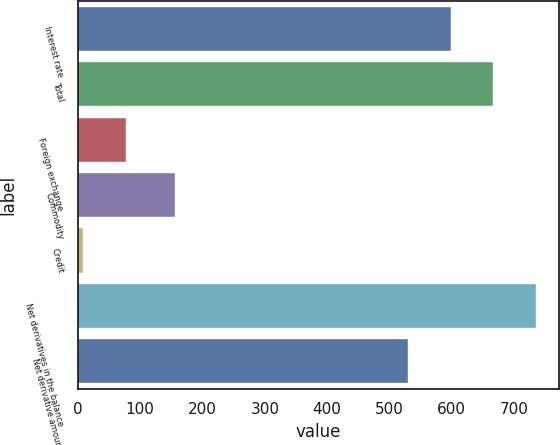Convert chart to OTSL. <chart><loc_0><loc_0><loc_500><loc_500><bar_chart><fcel>Interest rate<fcel>Total<fcel>Foreign exchange<fcel>Commodity<fcel>Credit<fcel>Net derivatives in the balance<fcel>Net derivative amounts<nl><fcel>598.4<fcel>666.8<fcel>77.4<fcel>156<fcel>9<fcel>735.2<fcel>530<nl></chart> 